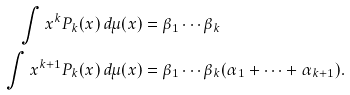<formula> <loc_0><loc_0><loc_500><loc_500>\int x ^ { k } P _ { k } ( x ) \, d \mu ( x ) & = \beta _ { 1 } \cdots \beta _ { k } \\ \int x ^ { k + 1 } P _ { k } ( x ) \, d \mu ( x ) & = \beta _ { 1 } \cdots \beta _ { k } ( \alpha _ { 1 } + \cdots + \alpha _ { k + 1 } ) .</formula> 